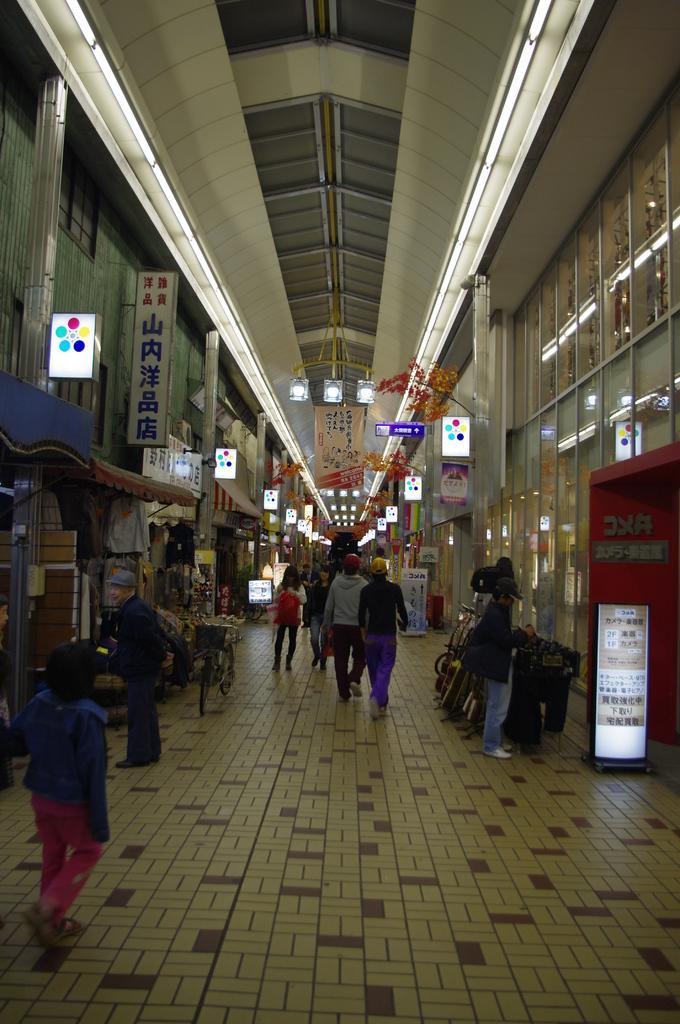In one or two sentences, can you explain what this image depicts? In this image there are few people walking. On the either sides of the image there are wall. There are windows and boards to the wall. At the top there is a ceiling. There are lights hanging to the ceiling. There are few boards on the ground. 